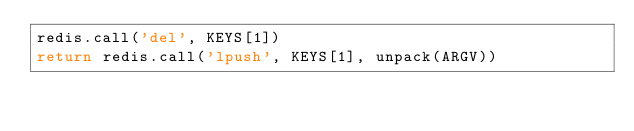Convert code to text. <code><loc_0><loc_0><loc_500><loc_500><_Lua_>redis.call('del', KEYS[1])
return redis.call('lpush', KEYS[1], unpack(ARGV))
</code> 